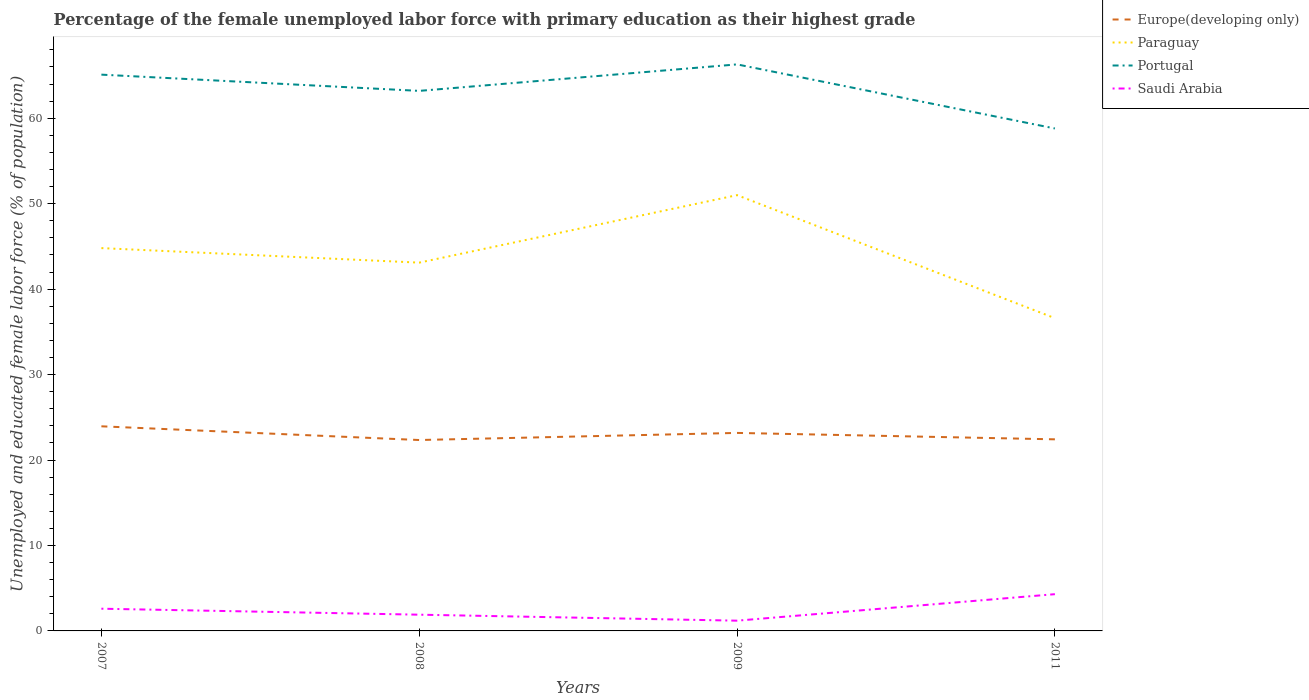Does the line corresponding to Portugal intersect with the line corresponding to Saudi Arabia?
Offer a very short reply. No. Is the number of lines equal to the number of legend labels?
Make the answer very short. Yes. Across all years, what is the maximum percentage of the unemployed female labor force with primary education in Saudi Arabia?
Your answer should be very brief. 1.2. In which year was the percentage of the unemployed female labor force with primary education in Paraguay maximum?
Give a very brief answer. 2011. What is the total percentage of the unemployed female labor force with primary education in Saudi Arabia in the graph?
Ensure brevity in your answer.  -1.7. What is the difference between the highest and the second highest percentage of the unemployed female labor force with primary education in Saudi Arabia?
Give a very brief answer. 3.1. Is the percentage of the unemployed female labor force with primary education in Europe(developing only) strictly greater than the percentage of the unemployed female labor force with primary education in Saudi Arabia over the years?
Your answer should be very brief. No. What is the difference between two consecutive major ticks on the Y-axis?
Provide a succinct answer. 10. Where does the legend appear in the graph?
Provide a short and direct response. Top right. What is the title of the graph?
Your answer should be very brief. Percentage of the female unemployed labor force with primary education as their highest grade. What is the label or title of the X-axis?
Offer a very short reply. Years. What is the label or title of the Y-axis?
Your answer should be very brief. Unemployed and educated female labor force (% of population). What is the Unemployed and educated female labor force (% of population) in Europe(developing only) in 2007?
Provide a succinct answer. 23.95. What is the Unemployed and educated female labor force (% of population) in Paraguay in 2007?
Your answer should be very brief. 44.8. What is the Unemployed and educated female labor force (% of population) in Portugal in 2007?
Your answer should be compact. 65.1. What is the Unemployed and educated female labor force (% of population) of Saudi Arabia in 2007?
Ensure brevity in your answer.  2.6. What is the Unemployed and educated female labor force (% of population) in Europe(developing only) in 2008?
Offer a terse response. 22.34. What is the Unemployed and educated female labor force (% of population) in Paraguay in 2008?
Provide a short and direct response. 43.1. What is the Unemployed and educated female labor force (% of population) of Portugal in 2008?
Keep it short and to the point. 63.2. What is the Unemployed and educated female labor force (% of population) in Saudi Arabia in 2008?
Your answer should be compact. 1.9. What is the Unemployed and educated female labor force (% of population) of Europe(developing only) in 2009?
Make the answer very short. 23.17. What is the Unemployed and educated female labor force (% of population) in Paraguay in 2009?
Your answer should be very brief. 51. What is the Unemployed and educated female labor force (% of population) of Portugal in 2009?
Your answer should be very brief. 66.3. What is the Unemployed and educated female labor force (% of population) of Saudi Arabia in 2009?
Give a very brief answer. 1.2. What is the Unemployed and educated female labor force (% of population) of Europe(developing only) in 2011?
Offer a very short reply. 22.42. What is the Unemployed and educated female labor force (% of population) in Paraguay in 2011?
Your answer should be compact. 36.6. What is the Unemployed and educated female labor force (% of population) in Portugal in 2011?
Make the answer very short. 58.8. What is the Unemployed and educated female labor force (% of population) in Saudi Arabia in 2011?
Ensure brevity in your answer.  4.3. Across all years, what is the maximum Unemployed and educated female labor force (% of population) in Europe(developing only)?
Give a very brief answer. 23.95. Across all years, what is the maximum Unemployed and educated female labor force (% of population) of Portugal?
Offer a terse response. 66.3. Across all years, what is the maximum Unemployed and educated female labor force (% of population) of Saudi Arabia?
Make the answer very short. 4.3. Across all years, what is the minimum Unemployed and educated female labor force (% of population) in Europe(developing only)?
Provide a succinct answer. 22.34. Across all years, what is the minimum Unemployed and educated female labor force (% of population) of Paraguay?
Provide a short and direct response. 36.6. Across all years, what is the minimum Unemployed and educated female labor force (% of population) of Portugal?
Provide a short and direct response. 58.8. Across all years, what is the minimum Unemployed and educated female labor force (% of population) of Saudi Arabia?
Ensure brevity in your answer.  1.2. What is the total Unemployed and educated female labor force (% of population) of Europe(developing only) in the graph?
Offer a terse response. 91.88. What is the total Unemployed and educated female labor force (% of population) in Paraguay in the graph?
Your answer should be very brief. 175.5. What is the total Unemployed and educated female labor force (% of population) in Portugal in the graph?
Your response must be concise. 253.4. What is the total Unemployed and educated female labor force (% of population) of Saudi Arabia in the graph?
Your answer should be compact. 10. What is the difference between the Unemployed and educated female labor force (% of population) of Europe(developing only) in 2007 and that in 2008?
Give a very brief answer. 1.6. What is the difference between the Unemployed and educated female labor force (% of population) in Paraguay in 2007 and that in 2008?
Ensure brevity in your answer.  1.7. What is the difference between the Unemployed and educated female labor force (% of population) in Saudi Arabia in 2007 and that in 2008?
Provide a short and direct response. 0.7. What is the difference between the Unemployed and educated female labor force (% of population) of Europe(developing only) in 2007 and that in 2009?
Offer a very short reply. 0.77. What is the difference between the Unemployed and educated female labor force (% of population) in Saudi Arabia in 2007 and that in 2009?
Provide a succinct answer. 1.4. What is the difference between the Unemployed and educated female labor force (% of population) in Europe(developing only) in 2007 and that in 2011?
Offer a terse response. 1.52. What is the difference between the Unemployed and educated female labor force (% of population) of Paraguay in 2007 and that in 2011?
Offer a very short reply. 8.2. What is the difference between the Unemployed and educated female labor force (% of population) in Saudi Arabia in 2007 and that in 2011?
Provide a short and direct response. -1.7. What is the difference between the Unemployed and educated female labor force (% of population) in Europe(developing only) in 2008 and that in 2009?
Provide a succinct answer. -0.83. What is the difference between the Unemployed and educated female labor force (% of population) in Europe(developing only) in 2008 and that in 2011?
Give a very brief answer. -0.08. What is the difference between the Unemployed and educated female labor force (% of population) of Portugal in 2008 and that in 2011?
Your answer should be very brief. 4.4. What is the difference between the Unemployed and educated female labor force (% of population) of Europe(developing only) in 2009 and that in 2011?
Provide a succinct answer. 0.75. What is the difference between the Unemployed and educated female labor force (% of population) in Paraguay in 2009 and that in 2011?
Make the answer very short. 14.4. What is the difference between the Unemployed and educated female labor force (% of population) in Portugal in 2009 and that in 2011?
Offer a terse response. 7.5. What is the difference between the Unemployed and educated female labor force (% of population) of Saudi Arabia in 2009 and that in 2011?
Provide a short and direct response. -3.1. What is the difference between the Unemployed and educated female labor force (% of population) in Europe(developing only) in 2007 and the Unemployed and educated female labor force (% of population) in Paraguay in 2008?
Your answer should be very brief. -19.15. What is the difference between the Unemployed and educated female labor force (% of population) of Europe(developing only) in 2007 and the Unemployed and educated female labor force (% of population) of Portugal in 2008?
Provide a succinct answer. -39.25. What is the difference between the Unemployed and educated female labor force (% of population) of Europe(developing only) in 2007 and the Unemployed and educated female labor force (% of population) of Saudi Arabia in 2008?
Ensure brevity in your answer.  22.05. What is the difference between the Unemployed and educated female labor force (% of population) in Paraguay in 2007 and the Unemployed and educated female labor force (% of population) in Portugal in 2008?
Offer a very short reply. -18.4. What is the difference between the Unemployed and educated female labor force (% of population) of Paraguay in 2007 and the Unemployed and educated female labor force (% of population) of Saudi Arabia in 2008?
Provide a succinct answer. 42.9. What is the difference between the Unemployed and educated female labor force (% of population) in Portugal in 2007 and the Unemployed and educated female labor force (% of population) in Saudi Arabia in 2008?
Make the answer very short. 63.2. What is the difference between the Unemployed and educated female labor force (% of population) in Europe(developing only) in 2007 and the Unemployed and educated female labor force (% of population) in Paraguay in 2009?
Your response must be concise. -27.05. What is the difference between the Unemployed and educated female labor force (% of population) in Europe(developing only) in 2007 and the Unemployed and educated female labor force (% of population) in Portugal in 2009?
Provide a short and direct response. -42.35. What is the difference between the Unemployed and educated female labor force (% of population) of Europe(developing only) in 2007 and the Unemployed and educated female labor force (% of population) of Saudi Arabia in 2009?
Give a very brief answer. 22.75. What is the difference between the Unemployed and educated female labor force (% of population) of Paraguay in 2007 and the Unemployed and educated female labor force (% of population) of Portugal in 2009?
Keep it short and to the point. -21.5. What is the difference between the Unemployed and educated female labor force (% of population) of Paraguay in 2007 and the Unemployed and educated female labor force (% of population) of Saudi Arabia in 2009?
Ensure brevity in your answer.  43.6. What is the difference between the Unemployed and educated female labor force (% of population) of Portugal in 2007 and the Unemployed and educated female labor force (% of population) of Saudi Arabia in 2009?
Your answer should be compact. 63.9. What is the difference between the Unemployed and educated female labor force (% of population) in Europe(developing only) in 2007 and the Unemployed and educated female labor force (% of population) in Paraguay in 2011?
Give a very brief answer. -12.65. What is the difference between the Unemployed and educated female labor force (% of population) in Europe(developing only) in 2007 and the Unemployed and educated female labor force (% of population) in Portugal in 2011?
Ensure brevity in your answer.  -34.85. What is the difference between the Unemployed and educated female labor force (% of population) in Europe(developing only) in 2007 and the Unemployed and educated female labor force (% of population) in Saudi Arabia in 2011?
Provide a short and direct response. 19.65. What is the difference between the Unemployed and educated female labor force (% of population) of Paraguay in 2007 and the Unemployed and educated female labor force (% of population) of Portugal in 2011?
Your answer should be compact. -14. What is the difference between the Unemployed and educated female labor force (% of population) of Paraguay in 2007 and the Unemployed and educated female labor force (% of population) of Saudi Arabia in 2011?
Your answer should be very brief. 40.5. What is the difference between the Unemployed and educated female labor force (% of population) in Portugal in 2007 and the Unemployed and educated female labor force (% of population) in Saudi Arabia in 2011?
Provide a short and direct response. 60.8. What is the difference between the Unemployed and educated female labor force (% of population) of Europe(developing only) in 2008 and the Unemployed and educated female labor force (% of population) of Paraguay in 2009?
Provide a short and direct response. -28.66. What is the difference between the Unemployed and educated female labor force (% of population) in Europe(developing only) in 2008 and the Unemployed and educated female labor force (% of population) in Portugal in 2009?
Ensure brevity in your answer.  -43.96. What is the difference between the Unemployed and educated female labor force (% of population) in Europe(developing only) in 2008 and the Unemployed and educated female labor force (% of population) in Saudi Arabia in 2009?
Your response must be concise. 21.14. What is the difference between the Unemployed and educated female labor force (% of population) in Paraguay in 2008 and the Unemployed and educated female labor force (% of population) in Portugal in 2009?
Offer a terse response. -23.2. What is the difference between the Unemployed and educated female labor force (% of population) of Paraguay in 2008 and the Unemployed and educated female labor force (% of population) of Saudi Arabia in 2009?
Provide a short and direct response. 41.9. What is the difference between the Unemployed and educated female labor force (% of population) of Europe(developing only) in 2008 and the Unemployed and educated female labor force (% of population) of Paraguay in 2011?
Ensure brevity in your answer.  -14.26. What is the difference between the Unemployed and educated female labor force (% of population) in Europe(developing only) in 2008 and the Unemployed and educated female labor force (% of population) in Portugal in 2011?
Ensure brevity in your answer.  -36.46. What is the difference between the Unemployed and educated female labor force (% of population) of Europe(developing only) in 2008 and the Unemployed and educated female labor force (% of population) of Saudi Arabia in 2011?
Give a very brief answer. 18.04. What is the difference between the Unemployed and educated female labor force (% of population) in Paraguay in 2008 and the Unemployed and educated female labor force (% of population) in Portugal in 2011?
Offer a terse response. -15.7. What is the difference between the Unemployed and educated female labor force (% of population) of Paraguay in 2008 and the Unemployed and educated female labor force (% of population) of Saudi Arabia in 2011?
Your answer should be compact. 38.8. What is the difference between the Unemployed and educated female labor force (% of population) of Portugal in 2008 and the Unemployed and educated female labor force (% of population) of Saudi Arabia in 2011?
Give a very brief answer. 58.9. What is the difference between the Unemployed and educated female labor force (% of population) in Europe(developing only) in 2009 and the Unemployed and educated female labor force (% of population) in Paraguay in 2011?
Your answer should be compact. -13.43. What is the difference between the Unemployed and educated female labor force (% of population) in Europe(developing only) in 2009 and the Unemployed and educated female labor force (% of population) in Portugal in 2011?
Provide a short and direct response. -35.63. What is the difference between the Unemployed and educated female labor force (% of population) in Europe(developing only) in 2009 and the Unemployed and educated female labor force (% of population) in Saudi Arabia in 2011?
Provide a short and direct response. 18.87. What is the difference between the Unemployed and educated female labor force (% of population) of Paraguay in 2009 and the Unemployed and educated female labor force (% of population) of Saudi Arabia in 2011?
Keep it short and to the point. 46.7. What is the difference between the Unemployed and educated female labor force (% of population) in Portugal in 2009 and the Unemployed and educated female labor force (% of population) in Saudi Arabia in 2011?
Keep it short and to the point. 62. What is the average Unemployed and educated female labor force (% of population) in Europe(developing only) per year?
Provide a succinct answer. 22.97. What is the average Unemployed and educated female labor force (% of population) of Paraguay per year?
Give a very brief answer. 43.88. What is the average Unemployed and educated female labor force (% of population) of Portugal per year?
Your response must be concise. 63.35. What is the average Unemployed and educated female labor force (% of population) in Saudi Arabia per year?
Provide a succinct answer. 2.5. In the year 2007, what is the difference between the Unemployed and educated female labor force (% of population) of Europe(developing only) and Unemployed and educated female labor force (% of population) of Paraguay?
Keep it short and to the point. -20.85. In the year 2007, what is the difference between the Unemployed and educated female labor force (% of population) in Europe(developing only) and Unemployed and educated female labor force (% of population) in Portugal?
Your response must be concise. -41.15. In the year 2007, what is the difference between the Unemployed and educated female labor force (% of population) in Europe(developing only) and Unemployed and educated female labor force (% of population) in Saudi Arabia?
Ensure brevity in your answer.  21.35. In the year 2007, what is the difference between the Unemployed and educated female labor force (% of population) of Paraguay and Unemployed and educated female labor force (% of population) of Portugal?
Provide a succinct answer. -20.3. In the year 2007, what is the difference between the Unemployed and educated female labor force (% of population) of Paraguay and Unemployed and educated female labor force (% of population) of Saudi Arabia?
Keep it short and to the point. 42.2. In the year 2007, what is the difference between the Unemployed and educated female labor force (% of population) of Portugal and Unemployed and educated female labor force (% of population) of Saudi Arabia?
Your answer should be very brief. 62.5. In the year 2008, what is the difference between the Unemployed and educated female labor force (% of population) in Europe(developing only) and Unemployed and educated female labor force (% of population) in Paraguay?
Provide a succinct answer. -20.76. In the year 2008, what is the difference between the Unemployed and educated female labor force (% of population) in Europe(developing only) and Unemployed and educated female labor force (% of population) in Portugal?
Your answer should be compact. -40.86. In the year 2008, what is the difference between the Unemployed and educated female labor force (% of population) in Europe(developing only) and Unemployed and educated female labor force (% of population) in Saudi Arabia?
Provide a short and direct response. 20.44. In the year 2008, what is the difference between the Unemployed and educated female labor force (% of population) in Paraguay and Unemployed and educated female labor force (% of population) in Portugal?
Provide a succinct answer. -20.1. In the year 2008, what is the difference between the Unemployed and educated female labor force (% of population) of Paraguay and Unemployed and educated female labor force (% of population) of Saudi Arabia?
Provide a succinct answer. 41.2. In the year 2008, what is the difference between the Unemployed and educated female labor force (% of population) of Portugal and Unemployed and educated female labor force (% of population) of Saudi Arabia?
Ensure brevity in your answer.  61.3. In the year 2009, what is the difference between the Unemployed and educated female labor force (% of population) in Europe(developing only) and Unemployed and educated female labor force (% of population) in Paraguay?
Offer a terse response. -27.83. In the year 2009, what is the difference between the Unemployed and educated female labor force (% of population) in Europe(developing only) and Unemployed and educated female labor force (% of population) in Portugal?
Provide a succinct answer. -43.13. In the year 2009, what is the difference between the Unemployed and educated female labor force (% of population) of Europe(developing only) and Unemployed and educated female labor force (% of population) of Saudi Arabia?
Your answer should be very brief. 21.97. In the year 2009, what is the difference between the Unemployed and educated female labor force (% of population) of Paraguay and Unemployed and educated female labor force (% of population) of Portugal?
Offer a terse response. -15.3. In the year 2009, what is the difference between the Unemployed and educated female labor force (% of population) of Paraguay and Unemployed and educated female labor force (% of population) of Saudi Arabia?
Provide a succinct answer. 49.8. In the year 2009, what is the difference between the Unemployed and educated female labor force (% of population) of Portugal and Unemployed and educated female labor force (% of population) of Saudi Arabia?
Make the answer very short. 65.1. In the year 2011, what is the difference between the Unemployed and educated female labor force (% of population) in Europe(developing only) and Unemployed and educated female labor force (% of population) in Paraguay?
Provide a succinct answer. -14.18. In the year 2011, what is the difference between the Unemployed and educated female labor force (% of population) of Europe(developing only) and Unemployed and educated female labor force (% of population) of Portugal?
Your answer should be compact. -36.38. In the year 2011, what is the difference between the Unemployed and educated female labor force (% of population) in Europe(developing only) and Unemployed and educated female labor force (% of population) in Saudi Arabia?
Keep it short and to the point. 18.12. In the year 2011, what is the difference between the Unemployed and educated female labor force (% of population) of Paraguay and Unemployed and educated female labor force (% of population) of Portugal?
Make the answer very short. -22.2. In the year 2011, what is the difference between the Unemployed and educated female labor force (% of population) of Paraguay and Unemployed and educated female labor force (% of population) of Saudi Arabia?
Provide a short and direct response. 32.3. In the year 2011, what is the difference between the Unemployed and educated female labor force (% of population) of Portugal and Unemployed and educated female labor force (% of population) of Saudi Arabia?
Ensure brevity in your answer.  54.5. What is the ratio of the Unemployed and educated female labor force (% of population) in Europe(developing only) in 2007 to that in 2008?
Keep it short and to the point. 1.07. What is the ratio of the Unemployed and educated female labor force (% of population) in Paraguay in 2007 to that in 2008?
Keep it short and to the point. 1.04. What is the ratio of the Unemployed and educated female labor force (% of population) of Portugal in 2007 to that in 2008?
Keep it short and to the point. 1.03. What is the ratio of the Unemployed and educated female labor force (% of population) of Saudi Arabia in 2007 to that in 2008?
Make the answer very short. 1.37. What is the ratio of the Unemployed and educated female labor force (% of population) of Europe(developing only) in 2007 to that in 2009?
Offer a terse response. 1.03. What is the ratio of the Unemployed and educated female labor force (% of population) of Paraguay in 2007 to that in 2009?
Offer a very short reply. 0.88. What is the ratio of the Unemployed and educated female labor force (% of population) of Portugal in 2007 to that in 2009?
Offer a terse response. 0.98. What is the ratio of the Unemployed and educated female labor force (% of population) of Saudi Arabia in 2007 to that in 2009?
Your answer should be very brief. 2.17. What is the ratio of the Unemployed and educated female labor force (% of population) in Europe(developing only) in 2007 to that in 2011?
Your response must be concise. 1.07. What is the ratio of the Unemployed and educated female labor force (% of population) in Paraguay in 2007 to that in 2011?
Provide a succinct answer. 1.22. What is the ratio of the Unemployed and educated female labor force (% of population) of Portugal in 2007 to that in 2011?
Provide a short and direct response. 1.11. What is the ratio of the Unemployed and educated female labor force (% of population) of Saudi Arabia in 2007 to that in 2011?
Provide a succinct answer. 0.6. What is the ratio of the Unemployed and educated female labor force (% of population) of Europe(developing only) in 2008 to that in 2009?
Your answer should be compact. 0.96. What is the ratio of the Unemployed and educated female labor force (% of population) in Paraguay in 2008 to that in 2009?
Offer a terse response. 0.85. What is the ratio of the Unemployed and educated female labor force (% of population) of Portugal in 2008 to that in 2009?
Make the answer very short. 0.95. What is the ratio of the Unemployed and educated female labor force (% of population) of Saudi Arabia in 2008 to that in 2009?
Your response must be concise. 1.58. What is the ratio of the Unemployed and educated female labor force (% of population) in Europe(developing only) in 2008 to that in 2011?
Ensure brevity in your answer.  1. What is the ratio of the Unemployed and educated female labor force (% of population) in Paraguay in 2008 to that in 2011?
Ensure brevity in your answer.  1.18. What is the ratio of the Unemployed and educated female labor force (% of population) of Portugal in 2008 to that in 2011?
Ensure brevity in your answer.  1.07. What is the ratio of the Unemployed and educated female labor force (% of population) of Saudi Arabia in 2008 to that in 2011?
Offer a very short reply. 0.44. What is the ratio of the Unemployed and educated female labor force (% of population) of Europe(developing only) in 2009 to that in 2011?
Provide a succinct answer. 1.03. What is the ratio of the Unemployed and educated female labor force (% of population) in Paraguay in 2009 to that in 2011?
Give a very brief answer. 1.39. What is the ratio of the Unemployed and educated female labor force (% of population) of Portugal in 2009 to that in 2011?
Your answer should be very brief. 1.13. What is the ratio of the Unemployed and educated female labor force (% of population) in Saudi Arabia in 2009 to that in 2011?
Ensure brevity in your answer.  0.28. What is the difference between the highest and the second highest Unemployed and educated female labor force (% of population) in Europe(developing only)?
Your response must be concise. 0.77. What is the difference between the highest and the second highest Unemployed and educated female labor force (% of population) in Saudi Arabia?
Provide a succinct answer. 1.7. What is the difference between the highest and the lowest Unemployed and educated female labor force (% of population) in Europe(developing only)?
Keep it short and to the point. 1.6. What is the difference between the highest and the lowest Unemployed and educated female labor force (% of population) in Saudi Arabia?
Provide a succinct answer. 3.1. 